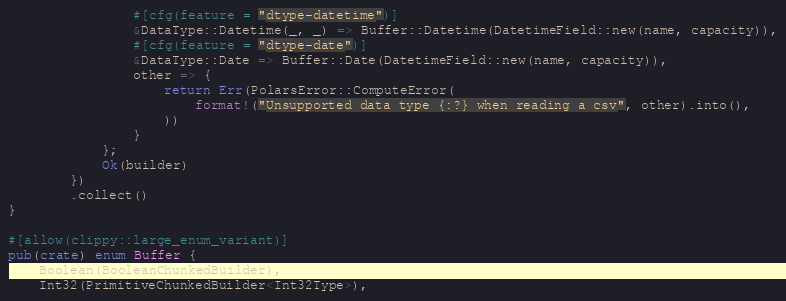<code> <loc_0><loc_0><loc_500><loc_500><_Rust_>                #[cfg(feature = "dtype-datetime")]
                &DataType::Datetime(_, _) => Buffer::Datetime(DatetimeField::new(name, capacity)),
                #[cfg(feature = "dtype-date")]
                &DataType::Date => Buffer::Date(DatetimeField::new(name, capacity)),
                other => {
                    return Err(PolarsError::ComputeError(
                        format!("Unsupported data type {:?} when reading a csv", other).into(),
                    ))
                }
            };
            Ok(builder)
        })
        .collect()
}

#[allow(clippy::large_enum_variant)]
pub(crate) enum Buffer {
    Boolean(BooleanChunkedBuilder),
    Int32(PrimitiveChunkedBuilder<Int32Type>),</code> 